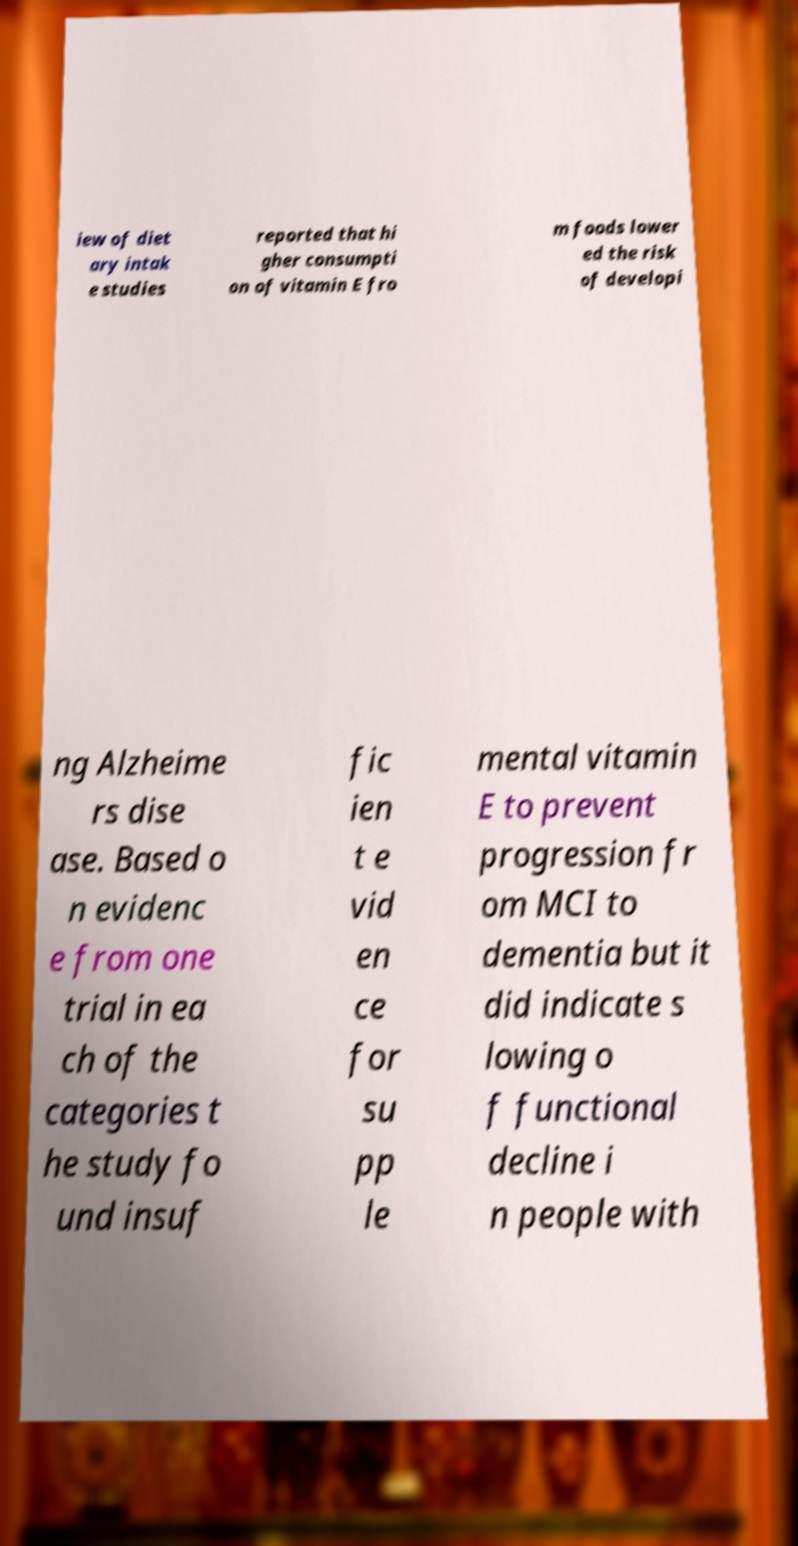Please identify and transcribe the text found in this image. iew of diet ary intak e studies reported that hi gher consumpti on of vitamin E fro m foods lower ed the risk of developi ng Alzheime rs dise ase. Based o n evidenc e from one trial in ea ch of the categories t he study fo und insuf fic ien t e vid en ce for su pp le mental vitamin E to prevent progression fr om MCI to dementia but it did indicate s lowing o f functional decline i n people with 